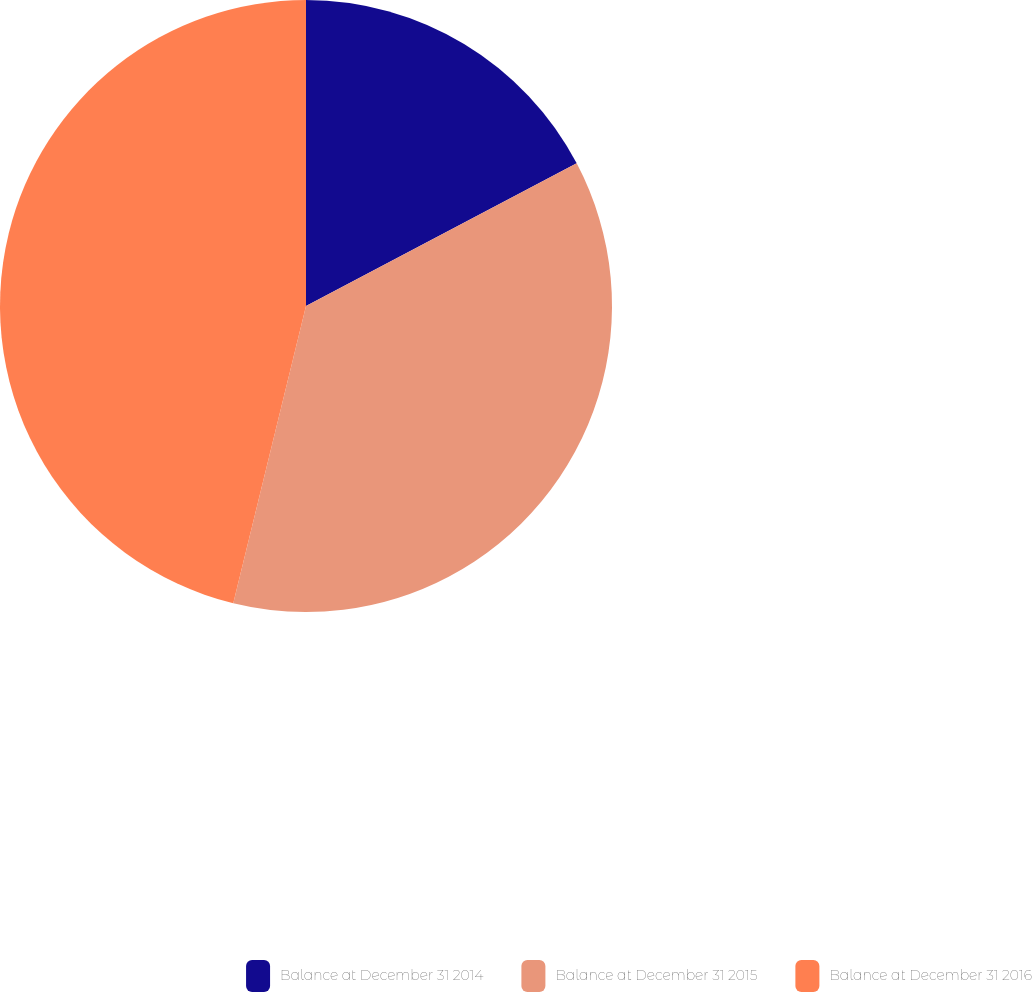Convert chart to OTSL. <chart><loc_0><loc_0><loc_500><loc_500><pie_chart><fcel>Balance at December 31 2014<fcel>Balance at December 31 2015<fcel>Balance at December 31 2016<nl><fcel>17.28%<fcel>36.54%<fcel>46.18%<nl></chart> 